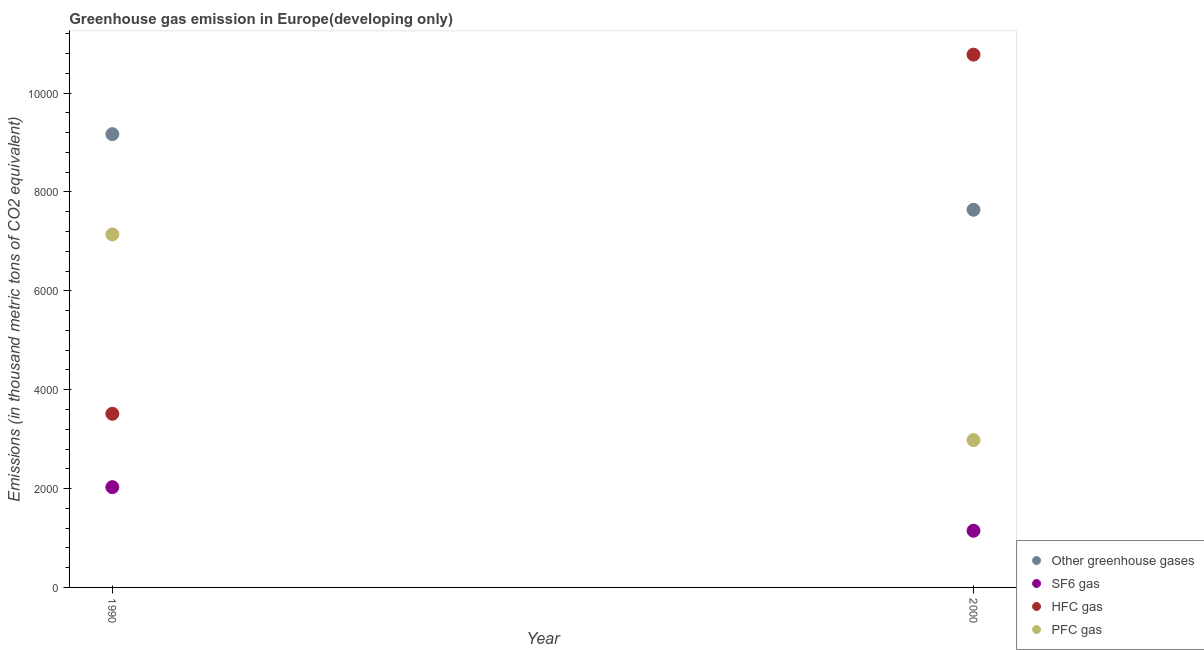What is the emission of pfc gas in 1990?
Keep it short and to the point. 7140.8. Across all years, what is the maximum emission of greenhouse gases?
Make the answer very short. 9170.1. Across all years, what is the minimum emission of pfc gas?
Offer a very short reply. 2981.2. In which year was the emission of sf6 gas maximum?
Your answer should be compact. 1990. What is the total emission of sf6 gas in the graph?
Offer a terse response. 3175.3. What is the difference between the emission of sf6 gas in 1990 and that in 2000?
Your answer should be compact. 882.1. What is the difference between the emission of pfc gas in 1990 and the emission of hfc gas in 2000?
Keep it short and to the point. -3637.93. What is the average emission of greenhouse gases per year?
Make the answer very short. 8405.4. In the year 2000, what is the difference between the emission of hfc gas and emission of greenhouse gases?
Provide a short and direct response. 3138.03. In how many years, is the emission of greenhouse gases greater than 2000 thousand metric tons?
Give a very brief answer. 2. What is the ratio of the emission of pfc gas in 1990 to that in 2000?
Ensure brevity in your answer.  2.4. Is the emission of hfc gas in 1990 less than that in 2000?
Your response must be concise. Yes. In how many years, is the emission of sf6 gas greater than the average emission of sf6 gas taken over all years?
Provide a short and direct response. 1. Is it the case that in every year, the sum of the emission of pfc gas and emission of sf6 gas is greater than the sum of emission of greenhouse gases and emission of hfc gas?
Your answer should be compact. Yes. Does the emission of hfc gas monotonically increase over the years?
Offer a very short reply. Yes. How many dotlines are there?
Give a very brief answer. 4. Does the graph contain any zero values?
Your answer should be very brief. No. Does the graph contain grids?
Your answer should be very brief. No. Where does the legend appear in the graph?
Your answer should be compact. Bottom right. How many legend labels are there?
Make the answer very short. 4. How are the legend labels stacked?
Provide a short and direct response. Vertical. What is the title of the graph?
Provide a short and direct response. Greenhouse gas emission in Europe(developing only). What is the label or title of the X-axis?
Your answer should be very brief. Year. What is the label or title of the Y-axis?
Offer a terse response. Emissions (in thousand metric tons of CO2 equivalent). What is the Emissions (in thousand metric tons of CO2 equivalent) of Other greenhouse gases in 1990?
Give a very brief answer. 9170.1. What is the Emissions (in thousand metric tons of CO2 equivalent) in SF6 gas in 1990?
Ensure brevity in your answer.  2028.7. What is the Emissions (in thousand metric tons of CO2 equivalent) of HFC gas in 1990?
Ensure brevity in your answer.  3512.9. What is the Emissions (in thousand metric tons of CO2 equivalent) in PFC gas in 1990?
Keep it short and to the point. 7140.8. What is the Emissions (in thousand metric tons of CO2 equivalent) of Other greenhouse gases in 2000?
Your answer should be very brief. 7640.7. What is the Emissions (in thousand metric tons of CO2 equivalent) of SF6 gas in 2000?
Offer a very short reply. 1146.6. What is the Emissions (in thousand metric tons of CO2 equivalent) in HFC gas in 2000?
Make the answer very short. 1.08e+04. What is the Emissions (in thousand metric tons of CO2 equivalent) of PFC gas in 2000?
Give a very brief answer. 2981.2. Across all years, what is the maximum Emissions (in thousand metric tons of CO2 equivalent) in Other greenhouse gases?
Offer a terse response. 9170.1. Across all years, what is the maximum Emissions (in thousand metric tons of CO2 equivalent) of SF6 gas?
Your answer should be compact. 2028.7. Across all years, what is the maximum Emissions (in thousand metric tons of CO2 equivalent) in HFC gas?
Your answer should be compact. 1.08e+04. Across all years, what is the maximum Emissions (in thousand metric tons of CO2 equivalent) of PFC gas?
Provide a short and direct response. 7140.8. Across all years, what is the minimum Emissions (in thousand metric tons of CO2 equivalent) of Other greenhouse gases?
Your answer should be very brief. 7640.7. Across all years, what is the minimum Emissions (in thousand metric tons of CO2 equivalent) of SF6 gas?
Give a very brief answer. 1146.6. Across all years, what is the minimum Emissions (in thousand metric tons of CO2 equivalent) in HFC gas?
Your answer should be compact. 3512.9. Across all years, what is the minimum Emissions (in thousand metric tons of CO2 equivalent) of PFC gas?
Your answer should be very brief. 2981.2. What is the total Emissions (in thousand metric tons of CO2 equivalent) of Other greenhouse gases in the graph?
Your answer should be very brief. 1.68e+04. What is the total Emissions (in thousand metric tons of CO2 equivalent) of SF6 gas in the graph?
Your response must be concise. 3175.3. What is the total Emissions (in thousand metric tons of CO2 equivalent) in HFC gas in the graph?
Provide a short and direct response. 1.43e+04. What is the total Emissions (in thousand metric tons of CO2 equivalent) in PFC gas in the graph?
Provide a succinct answer. 1.01e+04. What is the difference between the Emissions (in thousand metric tons of CO2 equivalent) of Other greenhouse gases in 1990 and that in 2000?
Offer a terse response. 1529.4. What is the difference between the Emissions (in thousand metric tons of CO2 equivalent) of SF6 gas in 1990 and that in 2000?
Ensure brevity in your answer.  882.1. What is the difference between the Emissions (in thousand metric tons of CO2 equivalent) of HFC gas in 1990 and that in 2000?
Your response must be concise. -7265.83. What is the difference between the Emissions (in thousand metric tons of CO2 equivalent) of PFC gas in 1990 and that in 2000?
Give a very brief answer. 4159.6. What is the difference between the Emissions (in thousand metric tons of CO2 equivalent) in Other greenhouse gases in 1990 and the Emissions (in thousand metric tons of CO2 equivalent) in SF6 gas in 2000?
Make the answer very short. 8023.5. What is the difference between the Emissions (in thousand metric tons of CO2 equivalent) of Other greenhouse gases in 1990 and the Emissions (in thousand metric tons of CO2 equivalent) of HFC gas in 2000?
Your response must be concise. -1608.63. What is the difference between the Emissions (in thousand metric tons of CO2 equivalent) in Other greenhouse gases in 1990 and the Emissions (in thousand metric tons of CO2 equivalent) in PFC gas in 2000?
Provide a succinct answer. 6188.9. What is the difference between the Emissions (in thousand metric tons of CO2 equivalent) in SF6 gas in 1990 and the Emissions (in thousand metric tons of CO2 equivalent) in HFC gas in 2000?
Give a very brief answer. -8750.03. What is the difference between the Emissions (in thousand metric tons of CO2 equivalent) in SF6 gas in 1990 and the Emissions (in thousand metric tons of CO2 equivalent) in PFC gas in 2000?
Your answer should be very brief. -952.5. What is the difference between the Emissions (in thousand metric tons of CO2 equivalent) of HFC gas in 1990 and the Emissions (in thousand metric tons of CO2 equivalent) of PFC gas in 2000?
Provide a short and direct response. 531.7. What is the average Emissions (in thousand metric tons of CO2 equivalent) of Other greenhouse gases per year?
Ensure brevity in your answer.  8405.4. What is the average Emissions (in thousand metric tons of CO2 equivalent) of SF6 gas per year?
Keep it short and to the point. 1587.65. What is the average Emissions (in thousand metric tons of CO2 equivalent) in HFC gas per year?
Offer a terse response. 7145.81. What is the average Emissions (in thousand metric tons of CO2 equivalent) of PFC gas per year?
Offer a very short reply. 5061. In the year 1990, what is the difference between the Emissions (in thousand metric tons of CO2 equivalent) in Other greenhouse gases and Emissions (in thousand metric tons of CO2 equivalent) in SF6 gas?
Give a very brief answer. 7141.4. In the year 1990, what is the difference between the Emissions (in thousand metric tons of CO2 equivalent) of Other greenhouse gases and Emissions (in thousand metric tons of CO2 equivalent) of HFC gas?
Provide a short and direct response. 5657.2. In the year 1990, what is the difference between the Emissions (in thousand metric tons of CO2 equivalent) in Other greenhouse gases and Emissions (in thousand metric tons of CO2 equivalent) in PFC gas?
Offer a very short reply. 2029.3. In the year 1990, what is the difference between the Emissions (in thousand metric tons of CO2 equivalent) in SF6 gas and Emissions (in thousand metric tons of CO2 equivalent) in HFC gas?
Offer a terse response. -1484.2. In the year 1990, what is the difference between the Emissions (in thousand metric tons of CO2 equivalent) in SF6 gas and Emissions (in thousand metric tons of CO2 equivalent) in PFC gas?
Offer a very short reply. -5112.1. In the year 1990, what is the difference between the Emissions (in thousand metric tons of CO2 equivalent) in HFC gas and Emissions (in thousand metric tons of CO2 equivalent) in PFC gas?
Make the answer very short. -3627.9. In the year 2000, what is the difference between the Emissions (in thousand metric tons of CO2 equivalent) in Other greenhouse gases and Emissions (in thousand metric tons of CO2 equivalent) in SF6 gas?
Your response must be concise. 6494.1. In the year 2000, what is the difference between the Emissions (in thousand metric tons of CO2 equivalent) in Other greenhouse gases and Emissions (in thousand metric tons of CO2 equivalent) in HFC gas?
Your response must be concise. -3138.03. In the year 2000, what is the difference between the Emissions (in thousand metric tons of CO2 equivalent) of Other greenhouse gases and Emissions (in thousand metric tons of CO2 equivalent) of PFC gas?
Ensure brevity in your answer.  4659.5. In the year 2000, what is the difference between the Emissions (in thousand metric tons of CO2 equivalent) of SF6 gas and Emissions (in thousand metric tons of CO2 equivalent) of HFC gas?
Provide a succinct answer. -9632.13. In the year 2000, what is the difference between the Emissions (in thousand metric tons of CO2 equivalent) of SF6 gas and Emissions (in thousand metric tons of CO2 equivalent) of PFC gas?
Your response must be concise. -1834.6. In the year 2000, what is the difference between the Emissions (in thousand metric tons of CO2 equivalent) of HFC gas and Emissions (in thousand metric tons of CO2 equivalent) of PFC gas?
Your answer should be very brief. 7797.53. What is the ratio of the Emissions (in thousand metric tons of CO2 equivalent) in Other greenhouse gases in 1990 to that in 2000?
Give a very brief answer. 1.2. What is the ratio of the Emissions (in thousand metric tons of CO2 equivalent) of SF6 gas in 1990 to that in 2000?
Provide a short and direct response. 1.77. What is the ratio of the Emissions (in thousand metric tons of CO2 equivalent) in HFC gas in 1990 to that in 2000?
Give a very brief answer. 0.33. What is the ratio of the Emissions (in thousand metric tons of CO2 equivalent) of PFC gas in 1990 to that in 2000?
Offer a terse response. 2.4. What is the difference between the highest and the second highest Emissions (in thousand metric tons of CO2 equivalent) of Other greenhouse gases?
Offer a very short reply. 1529.4. What is the difference between the highest and the second highest Emissions (in thousand metric tons of CO2 equivalent) in SF6 gas?
Your answer should be very brief. 882.1. What is the difference between the highest and the second highest Emissions (in thousand metric tons of CO2 equivalent) in HFC gas?
Provide a short and direct response. 7265.83. What is the difference between the highest and the second highest Emissions (in thousand metric tons of CO2 equivalent) of PFC gas?
Keep it short and to the point. 4159.6. What is the difference between the highest and the lowest Emissions (in thousand metric tons of CO2 equivalent) of Other greenhouse gases?
Give a very brief answer. 1529.4. What is the difference between the highest and the lowest Emissions (in thousand metric tons of CO2 equivalent) of SF6 gas?
Ensure brevity in your answer.  882.1. What is the difference between the highest and the lowest Emissions (in thousand metric tons of CO2 equivalent) in HFC gas?
Your answer should be very brief. 7265.83. What is the difference between the highest and the lowest Emissions (in thousand metric tons of CO2 equivalent) in PFC gas?
Give a very brief answer. 4159.6. 